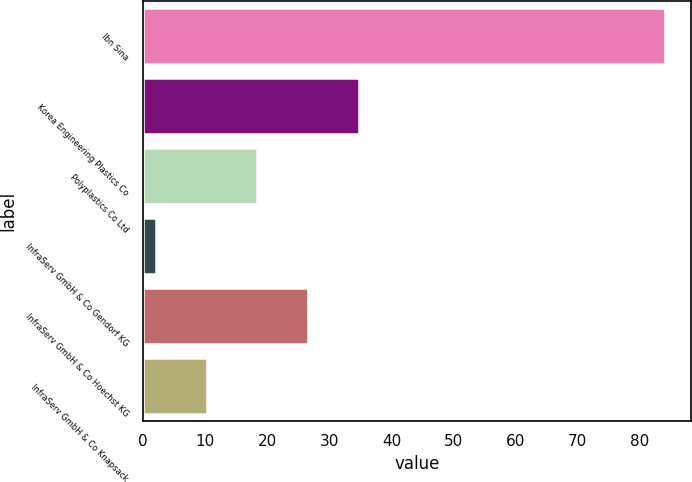Convert chart. <chart><loc_0><loc_0><loc_500><loc_500><bar_chart><fcel>Ibn Sina<fcel>Korea Engineering Plastics Co<fcel>Polyplastics Co Ltd<fcel>InfraServ GmbH & Co Gendorf KG<fcel>InfraServ GmbH & Co Hoechst KG<fcel>InfraServ GmbH & Co Knapsack<nl><fcel>84<fcel>34.8<fcel>18.4<fcel>2<fcel>26.6<fcel>10.2<nl></chart> 